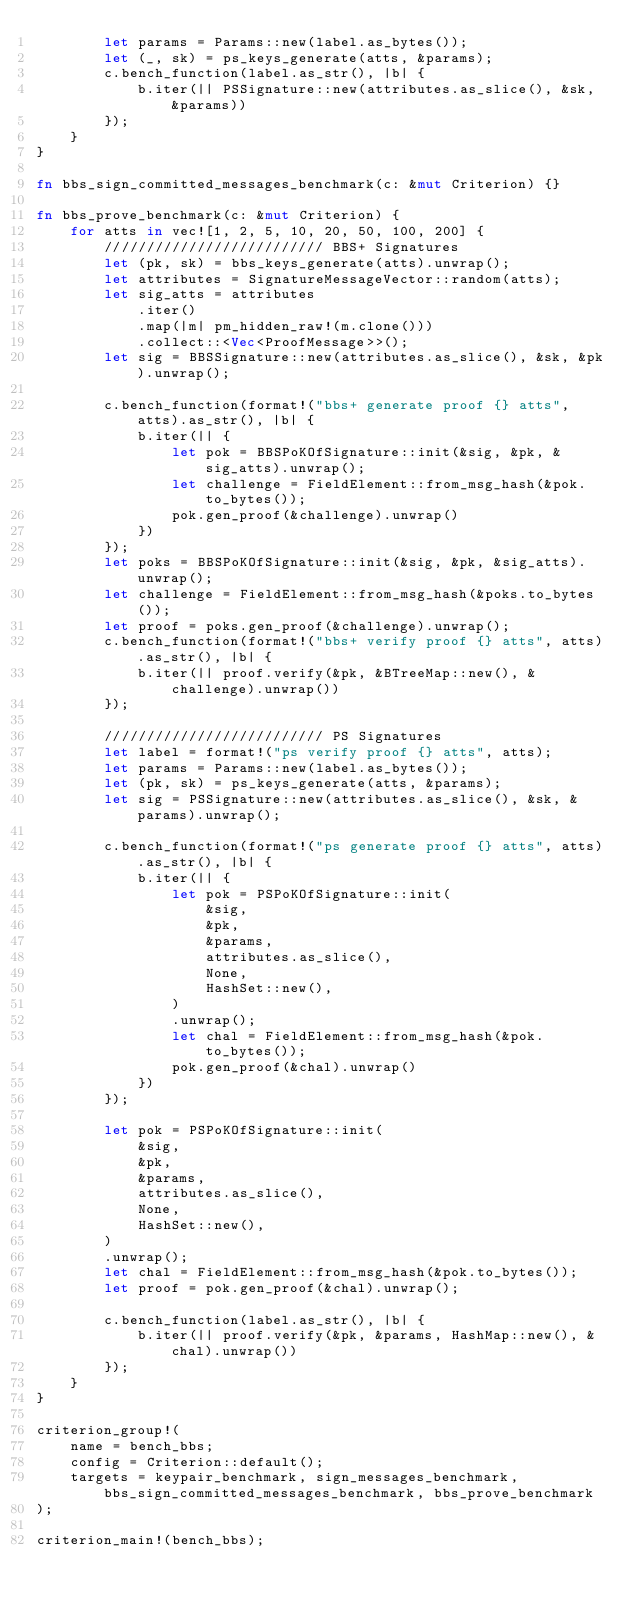Convert code to text. <code><loc_0><loc_0><loc_500><loc_500><_Rust_>        let params = Params::new(label.as_bytes());
        let (_, sk) = ps_keys_generate(atts, &params);
        c.bench_function(label.as_str(), |b| {
            b.iter(|| PSSignature::new(attributes.as_slice(), &sk, &params))
        });
    }
}

fn bbs_sign_committed_messages_benchmark(c: &mut Criterion) {}

fn bbs_prove_benchmark(c: &mut Criterion) {
    for atts in vec![1, 2, 5, 10, 20, 50, 100, 200] {
        ////////////////////////// BBS+ Signatures
        let (pk, sk) = bbs_keys_generate(atts).unwrap();
        let attributes = SignatureMessageVector::random(atts);
        let sig_atts = attributes
            .iter()
            .map(|m| pm_hidden_raw!(m.clone()))
            .collect::<Vec<ProofMessage>>();
        let sig = BBSSignature::new(attributes.as_slice(), &sk, &pk).unwrap();

        c.bench_function(format!("bbs+ generate proof {} atts", atts).as_str(), |b| {
            b.iter(|| {
                let pok = BBSPoKOfSignature::init(&sig, &pk, &sig_atts).unwrap();
                let challenge = FieldElement::from_msg_hash(&pok.to_bytes());
                pok.gen_proof(&challenge).unwrap()
            })
        });
        let poks = BBSPoKOfSignature::init(&sig, &pk, &sig_atts).unwrap();
        let challenge = FieldElement::from_msg_hash(&poks.to_bytes());
        let proof = poks.gen_proof(&challenge).unwrap();
        c.bench_function(format!("bbs+ verify proof {} atts", atts).as_str(), |b| {
            b.iter(|| proof.verify(&pk, &BTreeMap::new(), &challenge).unwrap())
        });

        ////////////////////////// PS Signatures
        let label = format!("ps verify proof {} atts", atts);
        let params = Params::new(label.as_bytes());
        let (pk, sk) = ps_keys_generate(atts, &params);
        let sig = PSSignature::new(attributes.as_slice(), &sk, &params).unwrap();

        c.bench_function(format!("ps generate proof {} atts", atts).as_str(), |b| {
            b.iter(|| {
                let pok = PSPoKOfSignature::init(
                    &sig,
                    &pk,
                    &params,
                    attributes.as_slice(),
                    None,
                    HashSet::new(),
                )
                .unwrap();
                let chal = FieldElement::from_msg_hash(&pok.to_bytes());
                pok.gen_proof(&chal).unwrap()
            })
        });

        let pok = PSPoKOfSignature::init(
            &sig,
            &pk,
            &params,
            attributes.as_slice(),
            None,
            HashSet::new(),
        )
        .unwrap();
        let chal = FieldElement::from_msg_hash(&pok.to_bytes());
        let proof = pok.gen_proof(&chal).unwrap();

        c.bench_function(label.as_str(), |b| {
            b.iter(|| proof.verify(&pk, &params, HashMap::new(), &chal).unwrap())
        });
    }
}

criterion_group!(
    name = bench_bbs;
    config = Criterion::default();
    targets = keypair_benchmark, sign_messages_benchmark, bbs_sign_committed_messages_benchmark, bbs_prove_benchmark
);

criterion_main!(bench_bbs);
</code> 